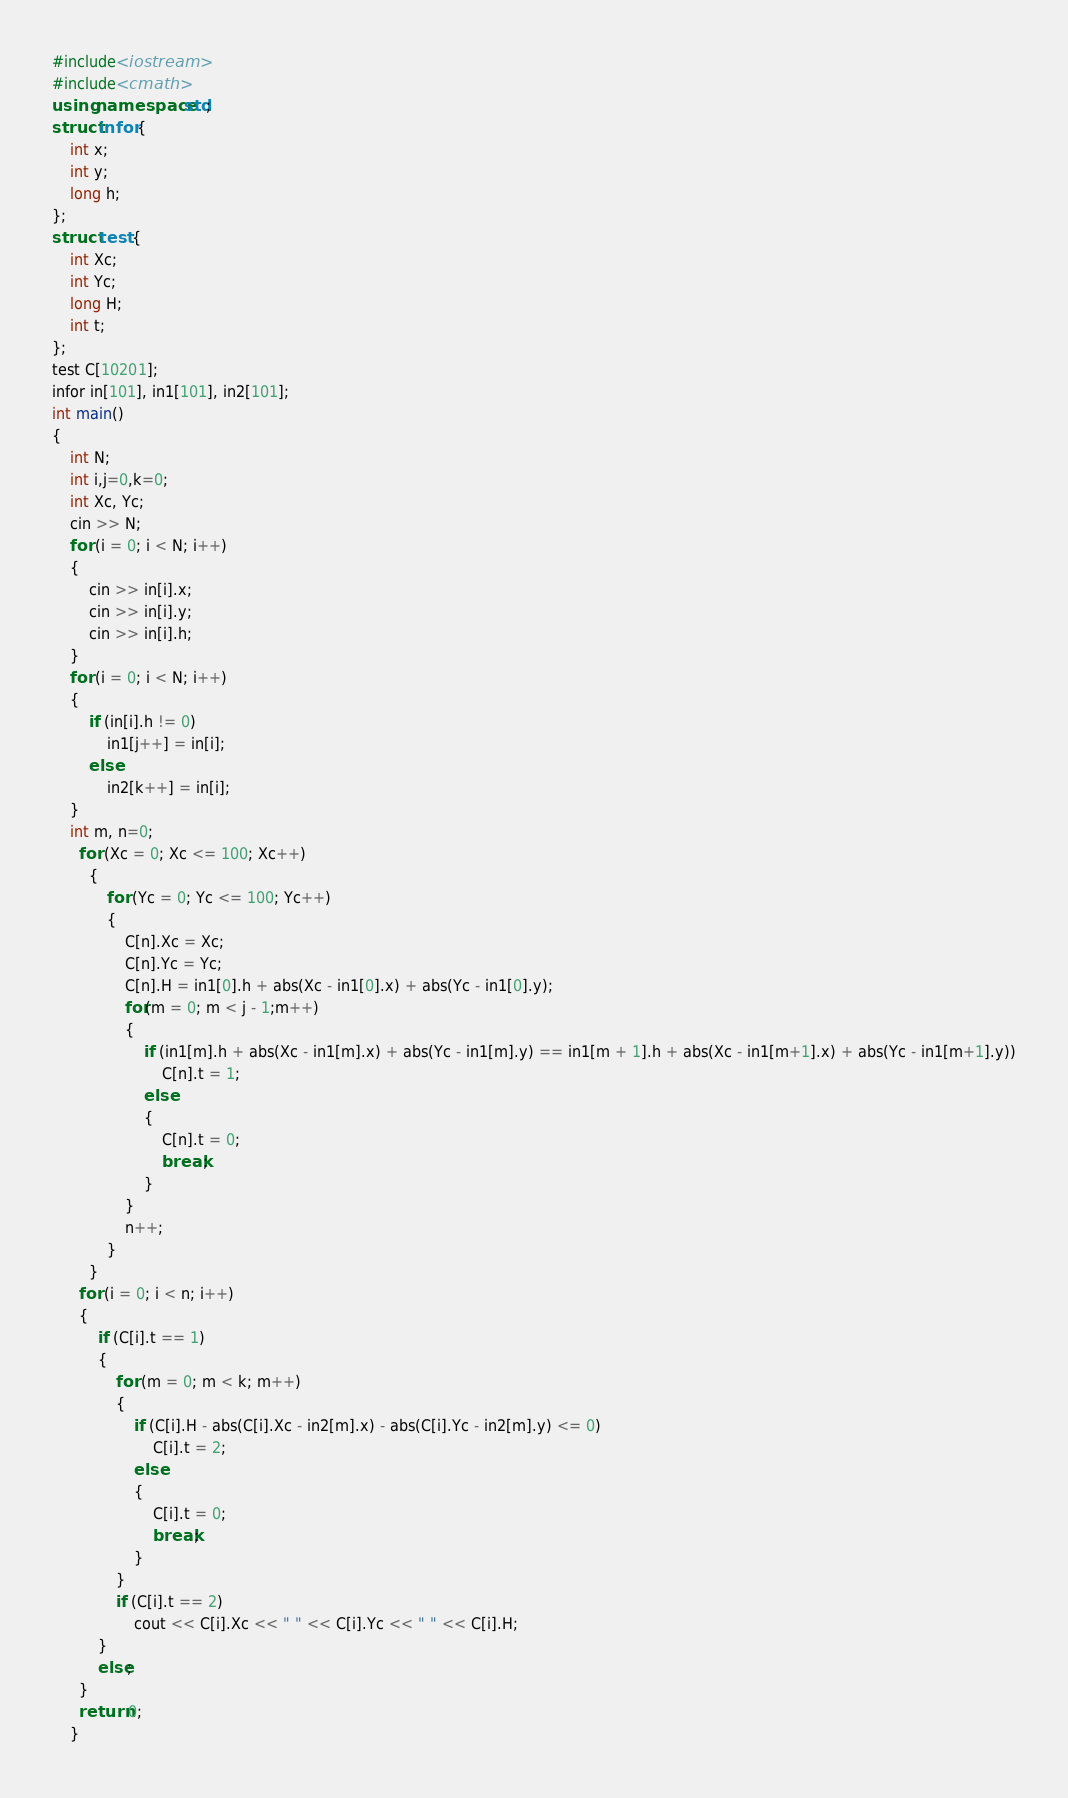<code> <loc_0><loc_0><loc_500><loc_500><_C++_>#include<iostream>
#include<cmath>
using namespace std;
struct infor {
	int x;
	int y;
	long h;
};
struct test {
	int Xc;
	int Yc;
	long H;
	int t;
};
test C[10201];
infor in[101], in1[101], in2[101];
int main()
{
	int N;
	int i,j=0,k=0;
	int Xc, Yc;
	cin >> N;
	for (i = 0; i < N; i++)
	{
		cin >> in[i].x;
		cin >> in[i].y;
		cin >> in[i].h;
	}
	for (i = 0; i < N; i++)
	{
		if (in[i].h != 0)
			in1[j++] = in[i];
		else
			in2[k++] = in[i];
	}
	int m, n=0;
      for (Xc = 0; Xc <= 100; Xc++)
		{
			for (Yc = 0; Yc <= 100; Yc++)
			{
				C[n].Xc = Xc;
				C[n].Yc = Yc;
				C[n].H = in1[0].h + abs(Xc - in1[0].x) + abs(Yc - in1[0].y);
				for(m = 0; m < j - 1;m++)
				{
					if (in1[m].h + abs(Xc - in1[m].x) + abs(Yc - in1[m].y) == in1[m + 1].h + abs(Xc - in1[m+1].x) + abs(Yc - in1[m+1].y))
						C[n].t = 1;
					else
					{
						C[n].t = 0;
						break;
					}
				}
				n++;
			}
		}
	  for (i = 0; i < n; i++)
	  {
		  if (C[i].t == 1)
		  {
			  for (m = 0; m < k; m++)
			  {
				  if (C[i].H - abs(C[i].Xc - in2[m].x) - abs(C[i].Yc - in2[m].y) <= 0)
					  C[i].t = 2;
				  else
				  {
					  C[i].t = 0;
					  break;
				  }
			  }
			  if (C[i].t == 2)
				  cout << C[i].Xc << " " << C[i].Yc << " " << C[i].H;
		  }
		  else;
	  }
	  return 0;
	}</code> 